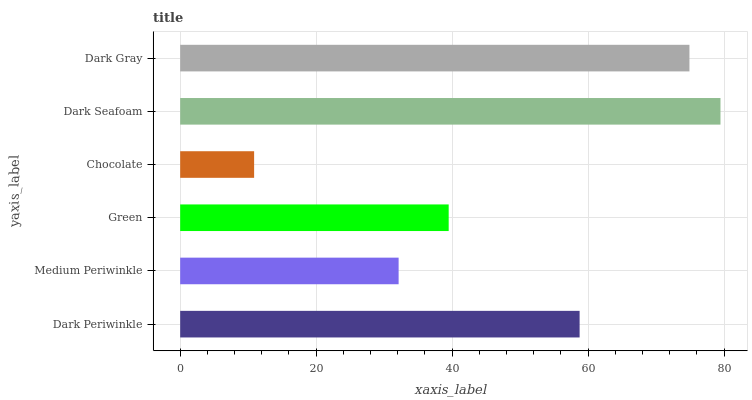Is Chocolate the minimum?
Answer yes or no. Yes. Is Dark Seafoam the maximum?
Answer yes or no. Yes. Is Medium Periwinkle the minimum?
Answer yes or no. No. Is Medium Periwinkle the maximum?
Answer yes or no. No. Is Dark Periwinkle greater than Medium Periwinkle?
Answer yes or no. Yes. Is Medium Periwinkle less than Dark Periwinkle?
Answer yes or no. Yes. Is Medium Periwinkle greater than Dark Periwinkle?
Answer yes or no. No. Is Dark Periwinkle less than Medium Periwinkle?
Answer yes or no. No. Is Dark Periwinkle the high median?
Answer yes or no. Yes. Is Green the low median?
Answer yes or no. Yes. Is Dark Seafoam the high median?
Answer yes or no. No. Is Dark Gray the low median?
Answer yes or no. No. 